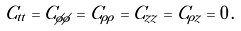<formula> <loc_0><loc_0><loc_500><loc_500>C _ { t t } = C _ { \phi \phi } = C _ { \rho \rho } = C _ { z z } = C _ { \rho z } = 0 \, .</formula> 